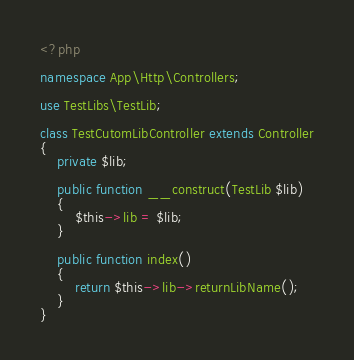Convert code to text. <code><loc_0><loc_0><loc_500><loc_500><_PHP_><?php

namespace App\Http\Controllers;

use TestLibs\TestLib;

class TestCutomLibController extends Controller
{
	private $lib;

	public function __construct(TestLib $lib)
	{
		$this->lib = $lib;
	}

	public function index()
	{
		return $this->lib->returnLibName();
	}
}
</code> 